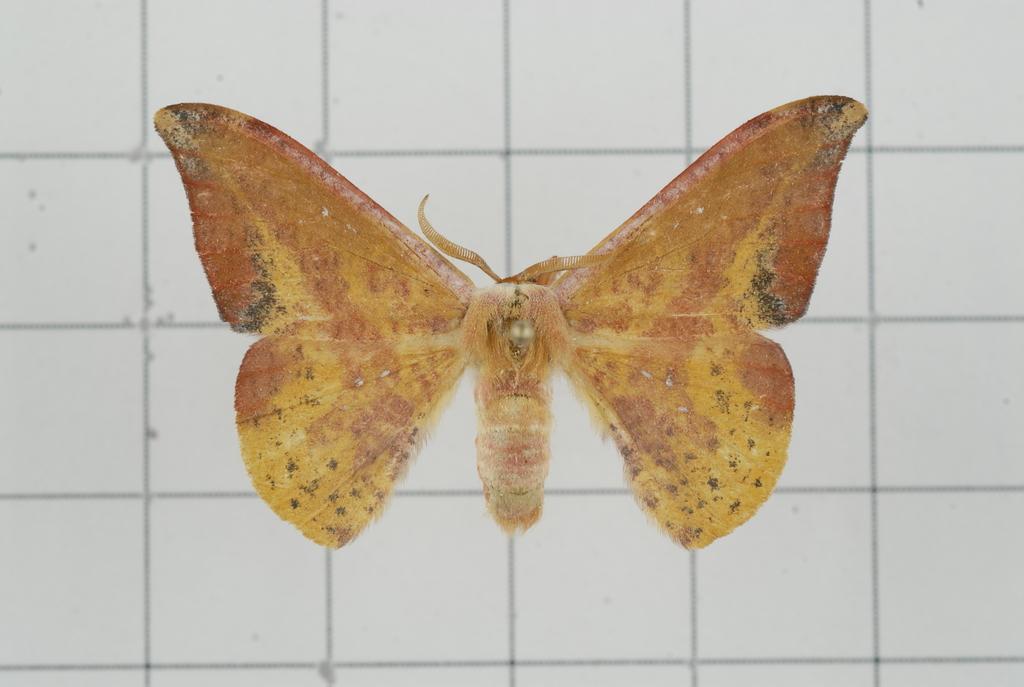Could you give a brief overview of what you see in this image? In this image, we can see a butterfly. In the background, there is an object. 